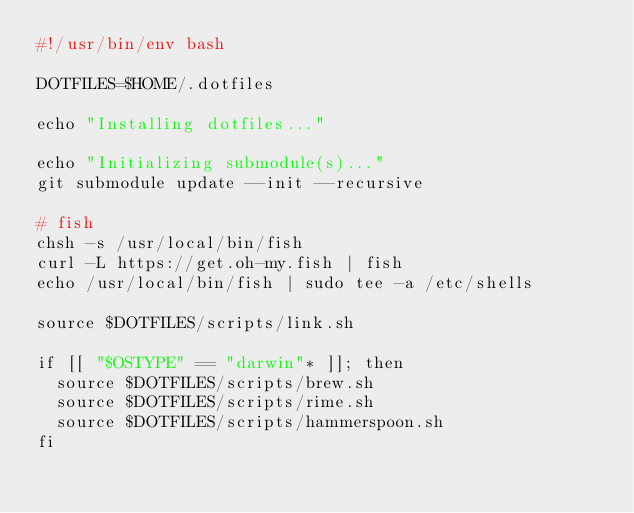Convert code to text. <code><loc_0><loc_0><loc_500><loc_500><_Bash_>#!/usr/bin/env bash

DOTFILES=$HOME/.dotfiles

echo "Installing dotfiles..."

echo "Initializing submodule(s)..."
git submodule update --init --recursive

# fish
chsh -s /usr/local/bin/fish
curl -L https://get.oh-my.fish | fish
echo /usr/local/bin/fish | sudo tee -a /etc/shells

source $DOTFILES/scripts/link.sh

if [[ "$OSTYPE" == "darwin"* ]]; then
  source $DOTFILES/scripts/brew.sh
  source $DOTFILES/scripts/rime.sh
  source $DOTFILES/scripts/hammerspoon.sh
fi
</code> 